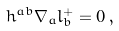Convert formula to latex. <formula><loc_0><loc_0><loc_500><loc_500>h ^ { a b } \nabla _ { a } l _ { b } ^ { + } = 0 \, ,</formula> 